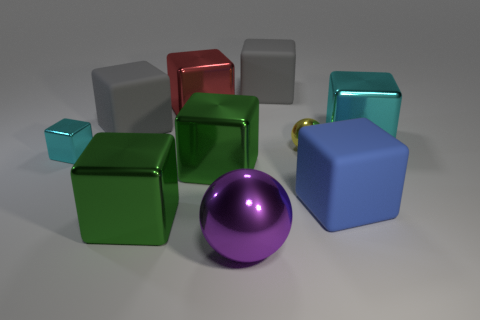Subtract all cyan blocks. How many blocks are left? 6 Subtract all large gray blocks. How many blocks are left? 6 Subtract all purple blocks. How many purple balls are left? 1 Subtract all spheres. How many objects are left? 8 Subtract 8 blocks. How many blocks are left? 0 Subtract all gray spheres. Subtract all red cylinders. How many spheres are left? 2 Subtract all big red things. Subtract all big shiny cubes. How many objects are left? 5 Add 7 big red cubes. How many big red cubes are left? 8 Add 10 green spheres. How many green spheres exist? 10 Subtract 0 red cylinders. How many objects are left? 10 